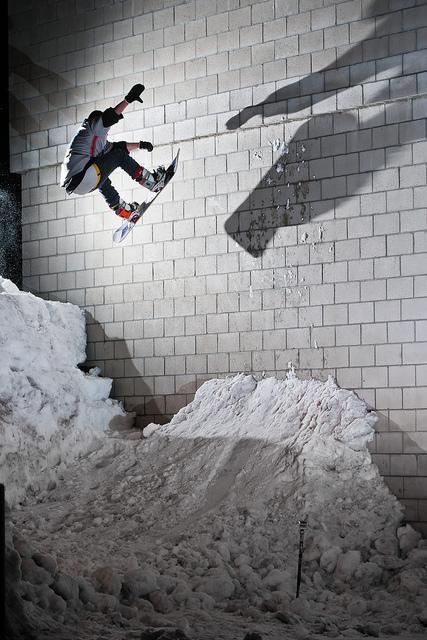How many people can you see?
Give a very brief answer. 1. How many light blue umbrellas are in the image?
Give a very brief answer. 0. 